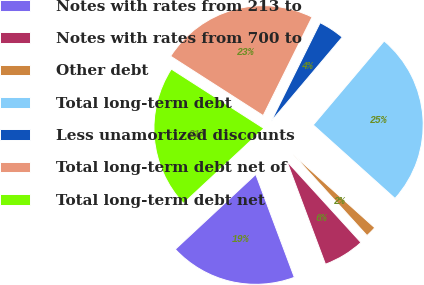Convert chart. <chart><loc_0><loc_0><loc_500><loc_500><pie_chart><fcel>Notes with rates from 213 to<fcel>Notes with rates from 700 to<fcel>Other debt<fcel>Total long-term debt<fcel>Less unamortized discounts<fcel>Total long-term debt net of<fcel>Total long-term debt net<nl><fcel>18.77%<fcel>6.06%<fcel>1.59%<fcel>25.48%<fcel>3.83%<fcel>23.25%<fcel>21.01%<nl></chart> 